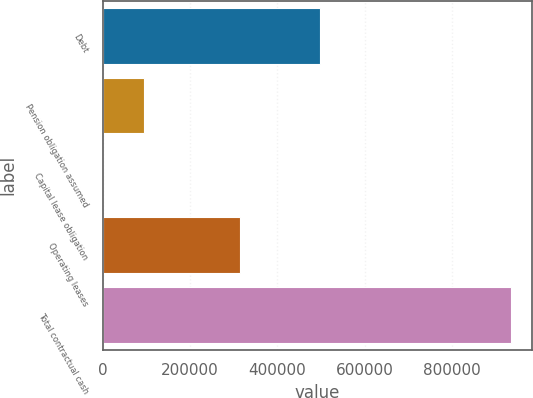Convert chart to OTSL. <chart><loc_0><loc_0><loc_500><loc_500><bar_chart><fcel>Debt<fcel>Pension obligation assumed<fcel>Capital lease obligation<fcel>Operating leases<fcel>Total contractual cash<nl><fcel>498916<fcel>94356.8<fcel>730<fcel>313264<fcel>936998<nl></chart> 